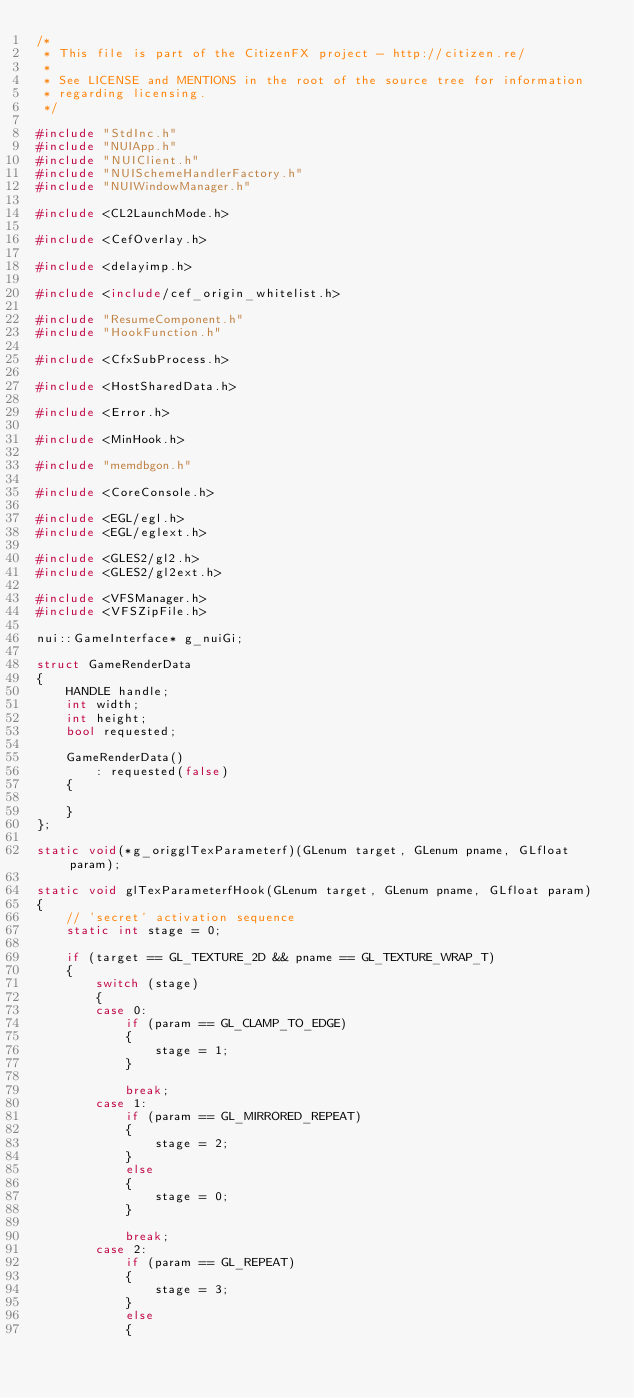<code> <loc_0><loc_0><loc_500><loc_500><_C++_>/*
 * This file is part of the CitizenFX project - http://citizen.re/
 *
 * See LICENSE and MENTIONS in the root of the source tree for information
 * regarding licensing.
 */

#include "StdInc.h"
#include "NUIApp.h"
#include "NUIClient.h"
#include "NUISchemeHandlerFactory.h"
#include "NUIWindowManager.h"

#include <CL2LaunchMode.h>

#include <CefOverlay.h>

#include <delayimp.h>

#include <include/cef_origin_whitelist.h>

#include "ResumeComponent.h"
#include "HookFunction.h"

#include <CfxSubProcess.h>

#include <HostSharedData.h>

#include <Error.h>

#include <MinHook.h>

#include "memdbgon.h"

#include <CoreConsole.h>

#include <EGL/egl.h>
#include <EGL/eglext.h>

#include <GLES2/gl2.h>
#include <GLES2/gl2ext.h>

#include <VFSManager.h>
#include <VFSZipFile.h>

nui::GameInterface* g_nuiGi;

struct GameRenderData
{
	HANDLE handle;
	int width;
	int height;
	bool requested;

	GameRenderData()
		: requested(false)
	{

	}
};

static void(*g_origglTexParameterf)(GLenum target, GLenum pname, GLfloat param);

static void glTexParameterfHook(GLenum target, GLenum pname, GLfloat param)
{
	// 'secret' activation sequence
	static int stage = 0;

	if (target == GL_TEXTURE_2D && pname == GL_TEXTURE_WRAP_T)
	{
		switch (stage)
		{
		case 0:
			if (param == GL_CLAMP_TO_EDGE)
			{
				stage = 1;
			}

			break;
		case 1:
			if (param == GL_MIRRORED_REPEAT)
			{
				stage = 2;
			}
			else
			{
				stage = 0;
			}

			break;
		case 2:
			if (param == GL_REPEAT)
			{
				stage = 3;
			}
			else
			{</code> 